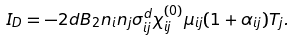Convert formula to latex. <formula><loc_0><loc_0><loc_500><loc_500>I _ { D } = - 2 d B _ { 2 } n _ { i } n _ { j } \sigma _ { i j } ^ { d } \chi _ { i j } ^ { ( 0 ) } \mu _ { i j } ( 1 + \alpha _ { i j } ) T _ { j } .</formula> 